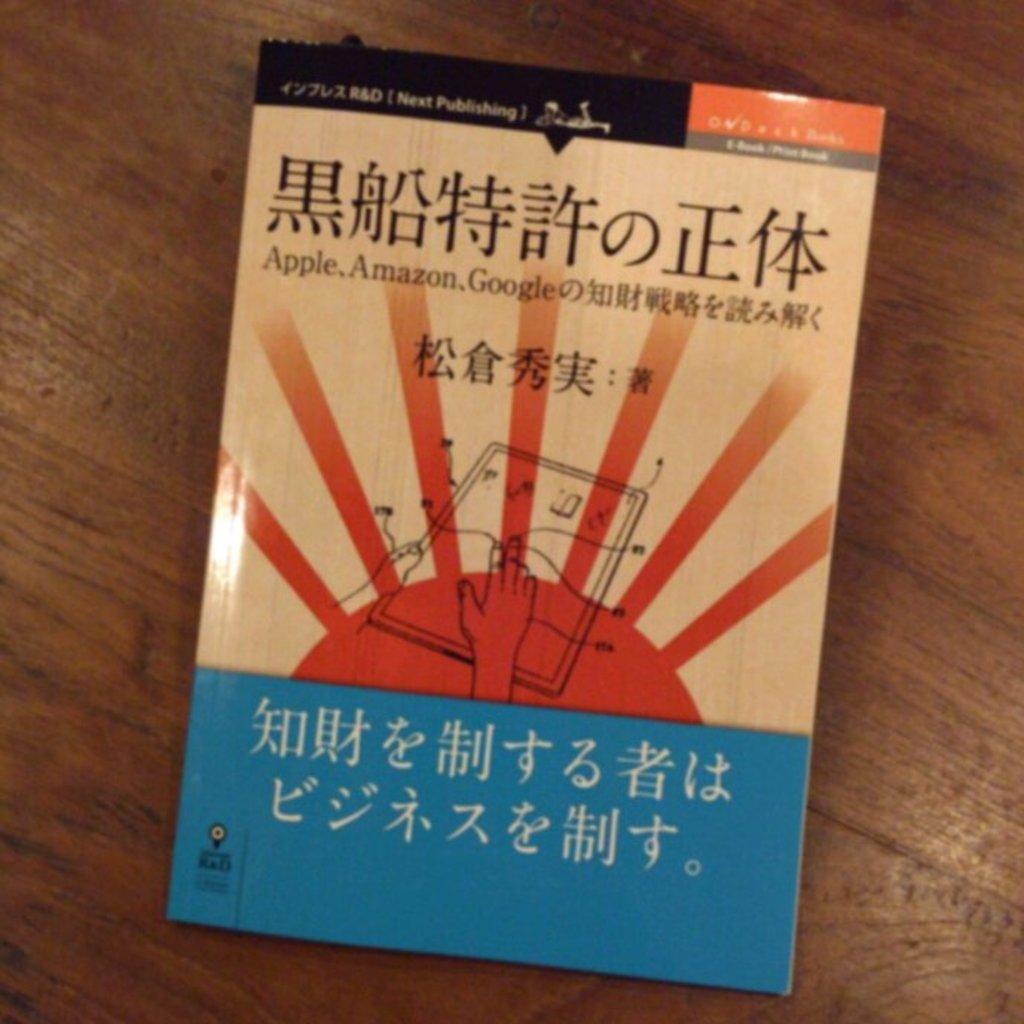What brands are shown in english?
Your answer should be very brief. Apple amazon google. 